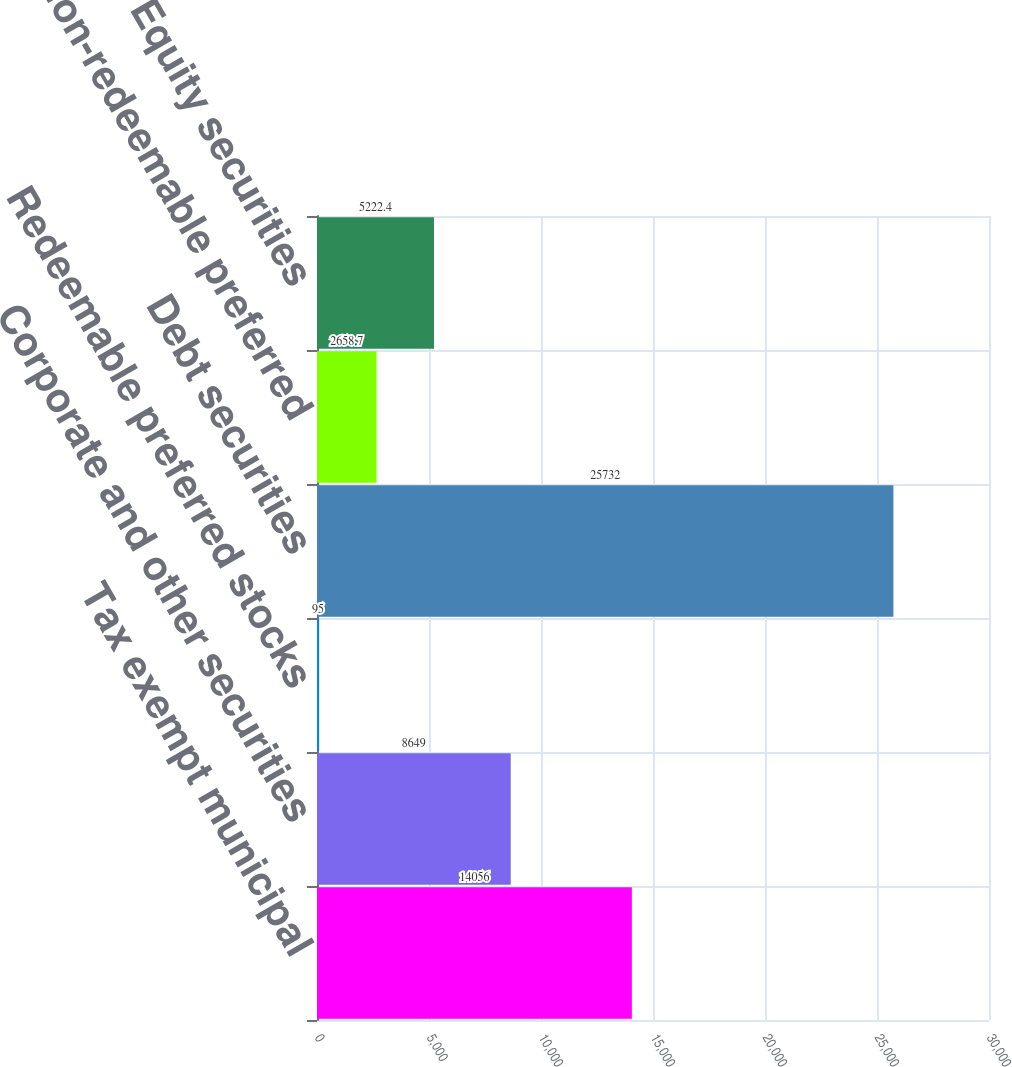Convert chart. <chart><loc_0><loc_0><loc_500><loc_500><bar_chart><fcel>Tax exempt municipal<fcel>Corporate and other securities<fcel>Redeemable preferred stocks<fcel>Debt securities<fcel>Non-redeemable preferred<fcel>Equity securities<nl><fcel>14056<fcel>8649<fcel>95<fcel>25732<fcel>2658.7<fcel>5222.4<nl></chart> 